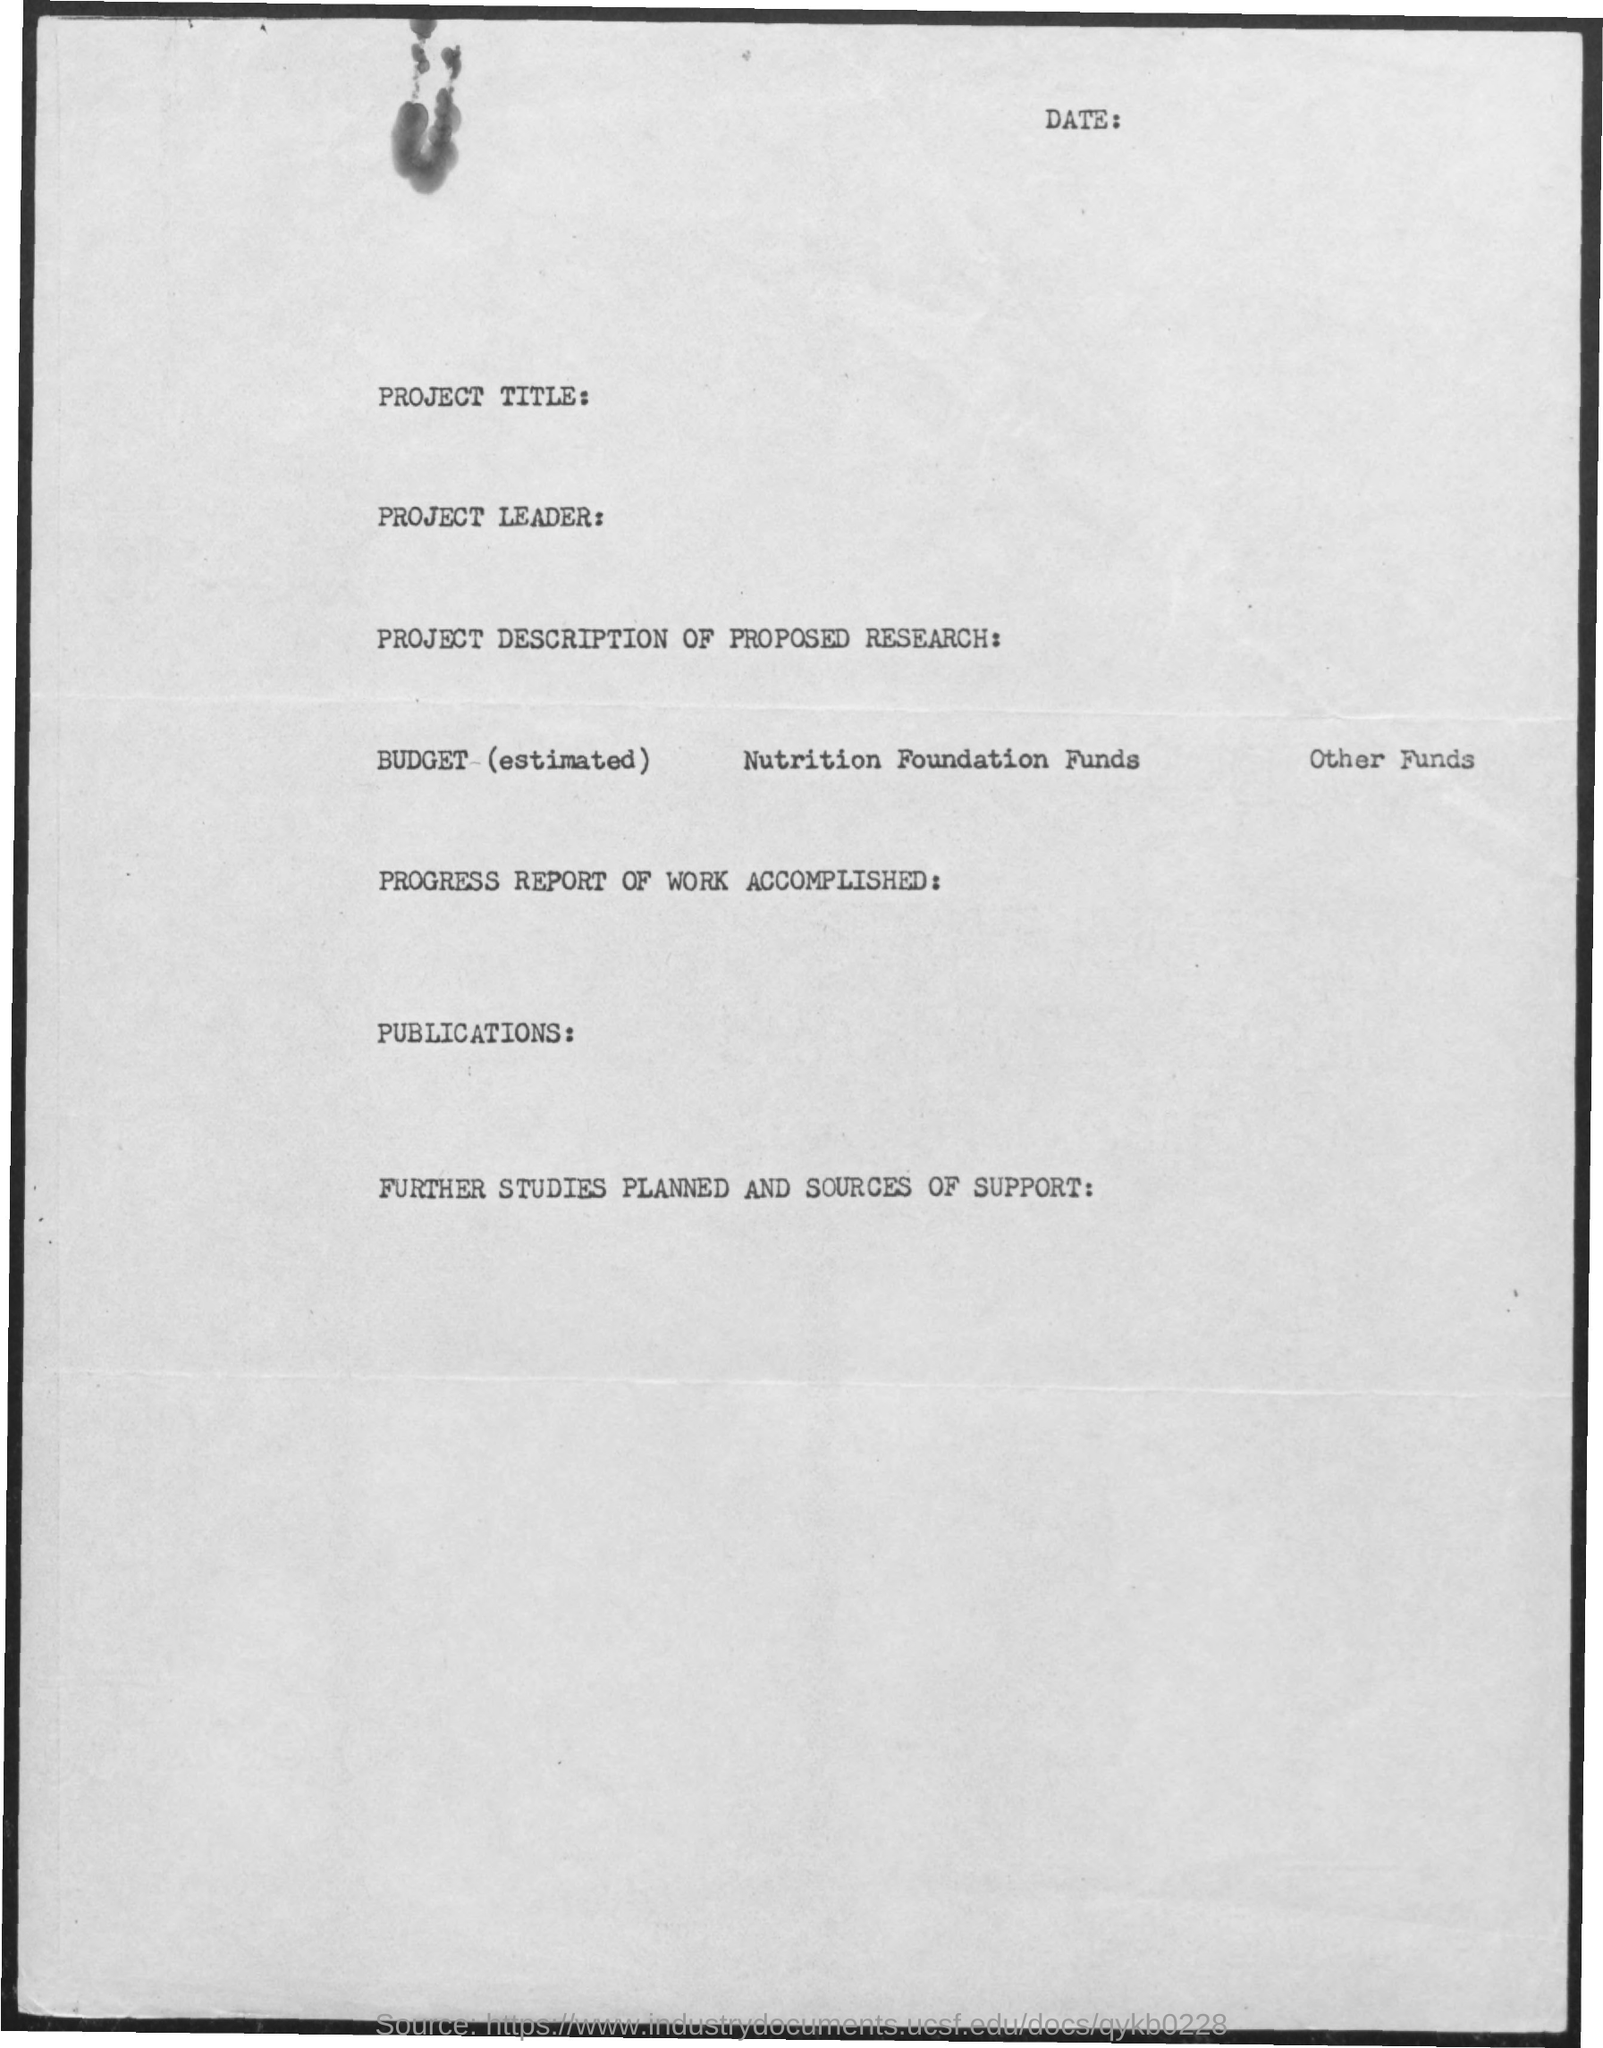What is the text written at the top?
Give a very brief answer. Date:. 